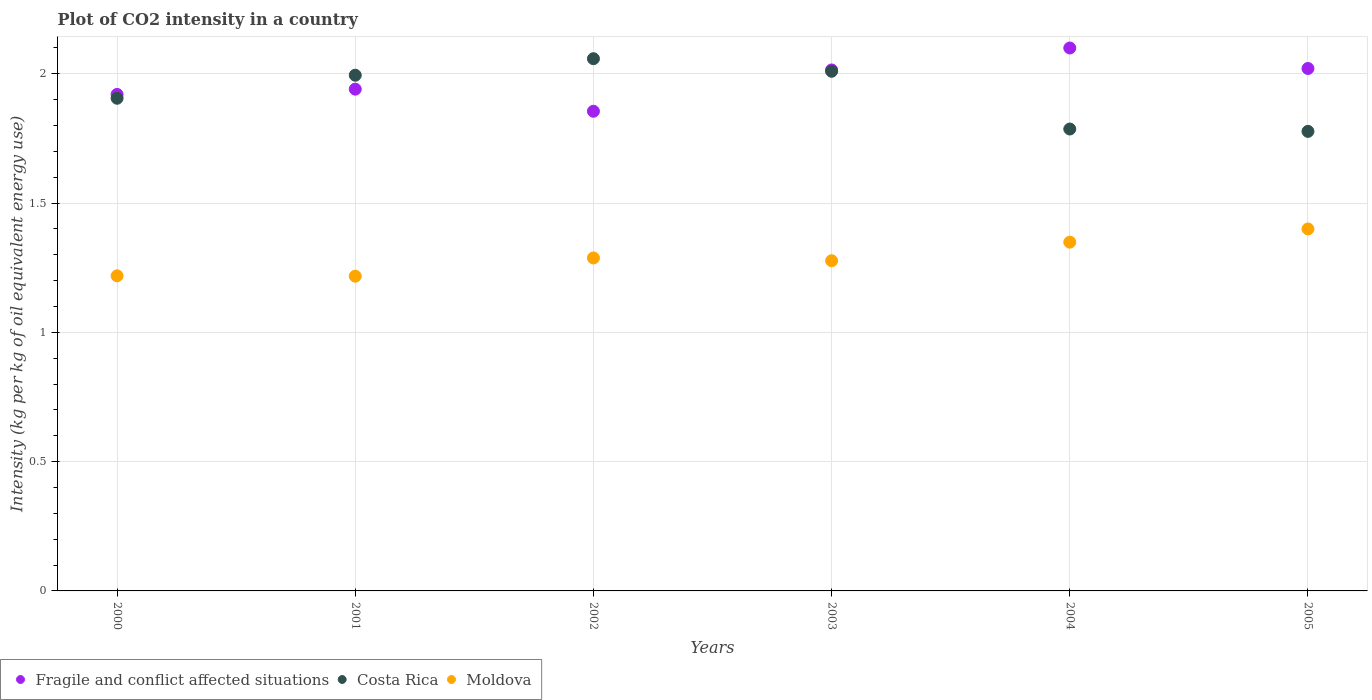What is the CO2 intensity in in Fragile and conflict affected situations in 2003?
Offer a very short reply. 2.01. Across all years, what is the maximum CO2 intensity in in Moldova?
Keep it short and to the point. 1.4. Across all years, what is the minimum CO2 intensity in in Costa Rica?
Your answer should be very brief. 1.78. In which year was the CO2 intensity in in Moldova maximum?
Keep it short and to the point. 2005. What is the total CO2 intensity in in Fragile and conflict affected situations in the graph?
Give a very brief answer. 11.85. What is the difference between the CO2 intensity in in Costa Rica in 2002 and that in 2004?
Make the answer very short. 0.27. What is the difference between the CO2 intensity in in Costa Rica in 2003 and the CO2 intensity in in Moldova in 2000?
Keep it short and to the point. 0.79. What is the average CO2 intensity in in Moldova per year?
Ensure brevity in your answer.  1.29. In the year 2003, what is the difference between the CO2 intensity in in Costa Rica and CO2 intensity in in Moldova?
Provide a short and direct response. 0.73. In how many years, is the CO2 intensity in in Fragile and conflict affected situations greater than 1.1 kg?
Provide a short and direct response. 6. What is the ratio of the CO2 intensity in in Moldova in 2002 to that in 2005?
Ensure brevity in your answer.  0.92. Is the difference between the CO2 intensity in in Costa Rica in 2000 and 2001 greater than the difference between the CO2 intensity in in Moldova in 2000 and 2001?
Your response must be concise. No. What is the difference between the highest and the second highest CO2 intensity in in Costa Rica?
Offer a very short reply. 0.05. What is the difference between the highest and the lowest CO2 intensity in in Moldova?
Ensure brevity in your answer.  0.18. Is it the case that in every year, the sum of the CO2 intensity in in Moldova and CO2 intensity in in Costa Rica  is greater than the CO2 intensity in in Fragile and conflict affected situations?
Your response must be concise. Yes. Is the CO2 intensity in in Moldova strictly greater than the CO2 intensity in in Costa Rica over the years?
Make the answer very short. No. Is the CO2 intensity in in Costa Rica strictly less than the CO2 intensity in in Fragile and conflict affected situations over the years?
Give a very brief answer. No. Are the values on the major ticks of Y-axis written in scientific E-notation?
Your answer should be compact. No. Does the graph contain any zero values?
Provide a short and direct response. No. How many legend labels are there?
Your answer should be compact. 3. What is the title of the graph?
Your response must be concise. Plot of CO2 intensity in a country. Does "Egypt, Arab Rep." appear as one of the legend labels in the graph?
Your response must be concise. No. What is the label or title of the Y-axis?
Provide a short and direct response. Intensity (kg per kg of oil equivalent energy use). What is the Intensity (kg per kg of oil equivalent energy use) of Fragile and conflict affected situations in 2000?
Offer a terse response. 1.92. What is the Intensity (kg per kg of oil equivalent energy use) of Costa Rica in 2000?
Provide a short and direct response. 1.91. What is the Intensity (kg per kg of oil equivalent energy use) in Moldova in 2000?
Give a very brief answer. 1.22. What is the Intensity (kg per kg of oil equivalent energy use) of Fragile and conflict affected situations in 2001?
Ensure brevity in your answer.  1.94. What is the Intensity (kg per kg of oil equivalent energy use) in Costa Rica in 2001?
Offer a very short reply. 1.99. What is the Intensity (kg per kg of oil equivalent energy use) in Moldova in 2001?
Your response must be concise. 1.22. What is the Intensity (kg per kg of oil equivalent energy use) of Fragile and conflict affected situations in 2002?
Your answer should be very brief. 1.85. What is the Intensity (kg per kg of oil equivalent energy use) of Costa Rica in 2002?
Ensure brevity in your answer.  2.06. What is the Intensity (kg per kg of oil equivalent energy use) in Moldova in 2002?
Provide a succinct answer. 1.29. What is the Intensity (kg per kg of oil equivalent energy use) of Fragile and conflict affected situations in 2003?
Your answer should be very brief. 2.01. What is the Intensity (kg per kg of oil equivalent energy use) in Costa Rica in 2003?
Give a very brief answer. 2.01. What is the Intensity (kg per kg of oil equivalent energy use) in Moldova in 2003?
Make the answer very short. 1.28. What is the Intensity (kg per kg of oil equivalent energy use) of Fragile and conflict affected situations in 2004?
Your answer should be compact. 2.1. What is the Intensity (kg per kg of oil equivalent energy use) in Costa Rica in 2004?
Make the answer very short. 1.79. What is the Intensity (kg per kg of oil equivalent energy use) in Moldova in 2004?
Give a very brief answer. 1.35. What is the Intensity (kg per kg of oil equivalent energy use) in Fragile and conflict affected situations in 2005?
Keep it short and to the point. 2.02. What is the Intensity (kg per kg of oil equivalent energy use) in Costa Rica in 2005?
Your response must be concise. 1.78. What is the Intensity (kg per kg of oil equivalent energy use) in Moldova in 2005?
Ensure brevity in your answer.  1.4. Across all years, what is the maximum Intensity (kg per kg of oil equivalent energy use) in Fragile and conflict affected situations?
Your response must be concise. 2.1. Across all years, what is the maximum Intensity (kg per kg of oil equivalent energy use) in Costa Rica?
Keep it short and to the point. 2.06. Across all years, what is the maximum Intensity (kg per kg of oil equivalent energy use) in Moldova?
Offer a terse response. 1.4. Across all years, what is the minimum Intensity (kg per kg of oil equivalent energy use) in Fragile and conflict affected situations?
Give a very brief answer. 1.85. Across all years, what is the minimum Intensity (kg per kg of oil equivalent energy use) in Costa Rica?
Provide a short and direct response. 1.78. Across all years, what is the minimum Intensity (kg per kg of oil equivalent energy use) in Moldova?
Offer a terse response. 1.22. What is the total Intensity (kg per kg of oil equivalent energy use) in Fragile and conflict affected situations in the graph?
Your answer should be very brief. 11.85. What is the total Intensity (kg per kg of oil equivalent energy use) in Costa Rica in the graph?
Your response must be concise. 11.53. What is the total Intensity (kg per kg of oil equivalent energy use) in Moldova in the graph?
Your response must be concise. 7.75. What is the difference between the Intensity (kg per kg of oil equivalent energy use) of Fragile and conflict affected situations in 2000 and that in 2001?
Give a very brief answer. -0.02. What is the difference between the Intensity (kg per kg of oil equivalent energy use) of Costa Rica in 2000 and that in 2001?
Give a very brief answer. -0.09. What is the difference between the Intensity (kg per kg of oil equivalent energy use) of Moldova in 2000 and that in 2001?
Ensure brevity in your answer.  0. What is the difference between the Intensity (kg per kg of oil equivalent energy use) of Fragile and conflict affected situations in 2000 and that in 2002?
Make the answer very short. 0.07. What is the difference between the Intensity (kg per kg of oil equivalent energy use) of Costa Rica in 2000 and that in 2002?
Provide a succinct answer. -0.15. What is the difference between the Intensity (kg per kg of oil equivalent energy use) in Moldova in 2000 and that in 2002?
Offer a terse response. -0.07. What is the difference between the Intensity (kg per kg of oil equivalent energy use) in Fragile and conflict affected situations in 2000 and that in 2003?
Ensure brevity in your answer.  -0.09. What is the difference between the Intensity (kg per kg of oil equivalent energy use) of Costa Rica in 2000 and that in 2003?
Offer a terse response. -0.1. What is the difference between the Intensity (kg per kg of oil equivalent energy use) of Moldova in 2000 and that in 2003?
Offer a very short reply. -0.06. What is the difference between the Intensity (kg per kg of oil equivalent energy use) of Fragile and conflict affected situations in 2000 and that in 2004?
Make the answer very short. -0.18. What is the difference between the Intensity (kg per kg of oil equivalent energy use) of Costa Rica in 2000 and that in 2004?
Ensure brevity in your answer.  0.12. What is the difference between the Intensity (kg per kg of oil equivalent energy use) in Moldova in 2000 and that in 2004?
Ensure brevity in your answer.  -0.13. What is the difference between the Intensity (kg per kg of oil equivalent energy use) of Fragile and conflict affected situations in 2000 and that in 2005?
Make the answer very short. -0.1. What is the difference between the Intensity (kg per kg of oil equivalent energy use) of Costa Rica in 2000 and that in 2005?
Your answer should be compact. 0.13. What is the difference between the Intensity (kg per kg of oil equivalent energy use) of Moldova in 2000 and that in 2005?
Offer a terse response. -0.18. What is the difference between the Intensity (kg per kg of oil equivalent energy use) in Fragile and conflict affected situations in 2001 and that in 2002?
Give a very brief answer. 0.09. What is the difference between the Intensity (kg per kg of oil equivalent energy use) in Costa Rica in 2001 and that in 2002?
Provide a short and direct response. -0.06. What is the difference between the Intensity (kg per kg of oil equivalent energy use) in Moldova in 2001 and that in 2002?
Your answer should be compact. -0.07. What is the difference between the Intensity (kg per kg of oil equivalent energy use) of Fragile and conflict affected situations in 2001 and that in 2003?
Provide a short and direct response. -0.07. What is the difference between the Intensity (kg per kg of oil equivalent energy use) of Costa Rica in 2001 and that in 2003?
Your answer should be compact. -0.02. What is the difference between the Intensity (kg per kg of oil equivalent energy use) of Moldova in 2001 and that in 2003?
Your answer should be compact. -0.06. What is the difference between the Intensity (kg per kg of oil equivalent energy use) in Fragile and conflict affected situations in 2001 and that in 2004?
Your answer should be very brief. -0.16. What is the difference between the Intensity (kg per kg of oil equivalent energy use) in Costa Rica in 2001 and that in 2004?
Provide a short and direct response. 0.21. What is the difference between the Intensity (kg per kg of oil equivalent energy use) of Moldova in 2001 and that in 2004?
Your answer should be compact. -0.13. What is the difference between the Intensity (kg per kg of oil equivalent energy use) of Fragile and conflict affected situations in 2001 and that in 2005?
Make the answer very short. -0.08. What is the difference between the Intensity (kg per kg of oil equivalent energy use) in Costa Rica in 2001 and that in 2005?
Give a very brief answer. 0.22. What is the difference between the Intensity (kg per kg of oil equivalent energy use) in Moldova in 2001 and that in 2005?
Provide a short and direct response. -0.18. What is the difference between the Intensity (kg per kg of oil equivalent energy use) in Fragile and conflict affected situations in 2002 and that in 2003?
Keep it short and to the point. -0.16. What is the difference between the Intensity (kg per kg of oil equivalent energy use) of Costa Rica in 2002 and that in 2003?
Your response must be concise. 0.05. What is the difference between the Intensity (kg per kg of oil equivalent energy use) in Moldova in 2002 and that in 2003?
Provide a short and direct response. 0.01. What is the difference between the Intensity (kg per kg of oil equivalent energy use) of Fragile and conflict affected situations in 2002 and that in 2004?
Make the answer very short. -0.24. What is the difference between the Intensity (kg per kg of oil equivalent energy use) of Costa Rica in 2002 and that in 2004?
Your response must be concise. 0.27. What is the difference between the Intensity (kg per kg of oil equivalent energy use) in Moldova in 2002 and that in 2004?
Your answer should be very brief. -0.06. What is the difference between the Intensity (kg per kg of oil equivalent energy use) in Fragile and conflict affected situations in 2002 and that in 2005?
Your response must be concise. -0.17. What is the difference between the Intensity (kg per kg of oil equivalent energy use) in Costa Rica in 2002 and that in 2005?
Your answer should be compact. 0.28. What is the difference between the Intensity (kg per kg of oil equivalent energy use) of Moldova in 2002 and that in 2005?
Your answer should be very brief. -0.11. What is the difference between the Intensity (kg per kg of oil equivalent energy use) in Fragile and conflict affected situations in 2003 and that in 2004?
Give a very brief answer. -0.08. What is the difference between the Intensity (kg per kg of oil equivalent energy use) in Costa Rica in 2003 and that in 2004?
Ensure brevity in your answer.  0.22. What is the difference between the Intensity (kg per kg of oil equivalent energy use) of Moldova in 2003 and that in 2004?
Offer a very short reply. -0.07. What is the difference between the Intensity (kg per kg of oil equivalent energy use) of Fragile and conflict affected situations in 2003 and that in 2005?
Give a very brief answer. -0.01. What is the difference between the Intensity (kg per kg of oil equivalent energy use) in Costa Rica in 2003 and that in 2005?
Keep it short and to the point. 0.23. What is the difference between the Intensity (kg per kg of oil equivalent energy use) of Moldova in 2003 and that in 2005?
Make the answer very short. -0.12. What is the difference between the Intensity (kg per kg of oil equivalent energy use) of Fragile and conflict affected situations in 2004 and that in 2005?
Offer a terse response. 0.08. What is the difference between the Intensity (kg per kg of oil equivalent energy use) in Costa Rica in 2004 and that in 2005?
Provide a succinct answer. 0.01. What is the difference between the Intensity (kg per kg of oil equivalent energy use) of Moldova in 2004 and that in 2005?
Offer a very short reply. -0.05. What is the difference between the Intensity (kg per kg of oil equivalent energy use) of Fragile and conflict affected situations in 2000 and the Intensity (kg per kg of oil equivalent energy use) of Costa Rica in 2001?
Provide a short and direct response. -0.07. What is the difference between the Intensity (kg per kg of oil equivalent energy use) in Fragile and conflict affected situations in 2000 and the Intensity (kg per kg of oil equivalent energy use) in Moldova in 2001?
Give a very brief answer. 0.7. What is the difference between the Intensity (kg per kg of oil equivalent energy use) of Costa Rica in 2000 and the Intensity (kg per kg of oil equivalent energy use) of Moldova in 2001?
Your response must be concise. 0.69. What is the difference between the Intensity (kg per kg of oil equivalent energy use) of Fragile and conflict affected situations in 2000 and the Intensity (kg per kg of oil equivalent energy use) of Costa Rica in 2002?
Your answer should be very brief. -0.14. What is the difference between the Intensity (kg per kg of oil equivalent energy use) in Fragile and conflict affected situations in 2000 and the Intensity (kg per kg of oil equivalent energy use) in Moldova in 2002?
Provide a succinct answer. 0.63. What is the difference between the Intensity (kg per kg of oil equivalent energy use) in Costa Rica in 2000 and the Intensity (kg per kg of oil equivalent energy use) in Moldova in 2002?
Offer a very short reply. 0.62. What is the difference between the Intensity (kg per kg of oil equivalent energy use) of Fragile and conflict affected situations in 2000 and the Intensity (kg per kg of oil equivalent energy use) of Costa Rica in 2003?
Your answer should be very brief. -0.09. What is the difference between the Intensity (kg per kg of oil equivalent energy use) in Fragile and conflict affected situations in 2000 and the Intensity (kg per kg of oil equivalent energy use) in Moldova in 2003?
Offer a terse response. 0.64. What is the difference between the Intensity (kg per kg of oil equivalent energy use) in Costa Rica in 2000 and the Intensity (kg per kg of oil equivalent energy use) in Moldova in 2003?
Provide a short and direct response. 0.63. What is the difference between the Intensity (kg per kg of oil equivalent energy use) in Fragile and conflict affected situations in 2000 and the Intensity (kg per kg of oil equivalent energy use) in Costa Rica in 2004?
Provide a short and direct response. 0.13. What is the difference between the Intensity (kg per kg of oil equivalent energy use) of Fragile and conflict affected situations in 2000 and the Intensity (kg per kg of oil equivalent energy use) of Moldova in 2004?
Ensure brevity in your answer.  0.57. What is the difference between the Intensity (kg per kg of oil equivalent energy use) in Costa Rica in 2000 and the Intensity (kg per kg of oil equivalent energy use) in Moldova in 2004?
Make the answer very short. 0.56. What is the difference between the Intensity (kg per kg of oil equivalent energy use) of Fragile and conflict affected situations in 2000 and the Intensity (kg per kg of oil equivalent energy use) of Costa Rica in 2005?
Offer a very short reply. 0.14. What is the difference between the Intensity (kg per kg of oil equivalent energy use) in Fragile and conflict affected situations in 2000 and the Intensity (kg per kg of oil equivalent energy use) in Moldova in 2005?
Ensure brevity in your answer.  0.52. What is the difference between the Intensity (kg per kg of oil equivalent energy use) of Costa Rica in 2000 and the Intensity (kg per kg of oil equivalent energy use) of Moldova in 2005?
Your response must be concise. 0.51. What is the difference between the Intensity (kg per kg of oil equivalent energy use) in Fragile and conflict affected situations in 2001 and the Intensity (kg per kg of oil equivalent energy use) in Costa Rica in 2002?
Make the answer very short. -0.12. What is the difference between the Intensity (kg per kg of oil equivalent energy use) of Fragile and conflict affected situations in 2001 and the Intensity (kg per kg of oil equivalent energy use) of Moldova in 2002?
Make the answer very short. 0.65. What is the difference between the Intensity (kg per kg of oil equivalent energy use) of Costa Rica in 2001 and the Intensity (kg per kg of oil equivalent energy use) of Moldova in 2002?
Your response must be concise. 0.71. What is the difference between the Intensity (kg per kg of oil equivalent energy use) in Fragile and conflict affected situations in 2001 and the Intensity (kg per kg of oil equivalent energy use) in Costa Rica in 2003?
Provide a succinct answer. -0.07. What is the difference between the Intensity (kg per kg of oil equivalent energy use) in Fragile and conflict affected situations in 2001 and the Intensity (kg per kg of oil equivalent energy use) in Moldova in 2003?
Ensure brevity in your answer.  0.66. What is the difference between the Intensity (kg per kg of oil equivalent energy use) in Costa Rica in 2001 and the Intensity (kg per kg of oil equivalent energy use) in Moldova in 2003?
Ensure brevity in your answer.  0.72. What is the difference between the Intensity (kg per kg of oil equivalent energy use) of Fragile and conflict affected situations in 2001 and the Intensity (kg per kg of oil equivalent energy use) of Costa Rica in 2004?
Give a very brief answer. 0.15. What is the difference between the Intensity (kg per kg of oil equivalent energy use) of Fragile and conflict affected situations in 2001 and the Intensity (kg per kg of oil equivalent energy use) of Moldova in 2004?
Offer a very short reply. 0.59. What is the difference between the Intensity (kg per kg of oil equivalent energy use) in Costa Rica in 2001 and the Intensity (kg per kg of oil equivalent energy use) in Moldova in 2004?
Your response must be concise. 0.65. What is the difference between the Intensity (kg per kg of oil equivalent energy use) in Fragile and conflict affected situations in 2001 and the Intensity (kg per kg of oil equivalent energy use) in Costa Rica in 2005?
Offer a very short reply. 0.16. What is the difference between the Intensity (kg per kg of oil equivalent energy use) of Fragile and conflict affected situations in 2001 and the Intensity (kg per kg of oil equivalent energy use) of Moldova in 2005?
Keep it short and to the point. 0.54. What is the difference between the Intensity (kg per kg of oil equivalent energy use) in Costa Rica in 2001 and the Intensity (kg per kg of oil equivalent energy use) in Moldova in 2005?
Give a very brief answer. 0.59. What is the difference between the Intensity (kg per kg of oil equivalent energy use) of Fragile and conflict affected situations in 2002 and the Intensity (kg per kg of oil equivalent energy use) of Costa Rica in 2003?
Your answer should be very brief. -0.15. What is the difference between the Intensity (kg per kg of oil equivalent energy use) of Fragile and conflict affected situations in 2002 and the Intensity (kg per kg of oil equivalent energy use) of Moldova in 2003?
Ensure brevity in your answer.  0.58. What is the difference between the Intensity (kg per kg of oil equivalent energy use) of Costa Rica in 2002 and the Intensity (kg per kg of oil equivalent energy use) of Moldova in 2003?
Ensure brevity in your answer.  0.78. What is the difference between the Intensity (kg per kg of oil equivalent energy use) of Fragile and conflict affected situations in 2002 and the Intensity (kg per kg of oil equivalent energy use) of Costa Rica in 2004?
Make the answer very short. 0.07. What is the difference between the Intensity (kg per kg of oil equivalent energy use) of Fragile and conflict affected situations in 2002 and the Intensity (kg per kg of oil equivalent energy use) of Moldova in 2004?
Give a very brief answer. 0.51. What is the difference between the Intensity (kg per kg of oil equivalent energy use) of Costa Rica in 2002 and the Intensity (kg per kg of oil equivalent energy use) of Moldova in 2004?
Offer a very short reply. 0.71. What is the difference between the Intensity (kg per kg of oil equivalent energy use) in Fragile and conflict affected situations in 2002 and the Intensity (kg per kg of oil equivalent energy use) in Costa Rica in 2005?
Give a very brief answer. 0.08. What is the difference between the Intensity (kg per kg of oil equivalent energy use) in Fragile and conflict affected situations in 2002 and the Intensity (kg per kg of oil equivalent energy use) in Moldova in 2005?
Ensure brevity in your answer.  0.46. What is the difference between the Intensity (kg per kg of oil equivalent energy use) in Costa Rica in 2002 and the Intensity (kg per kg of oil equivalent energy use) in Moldova in 2005?
Offer a terse response. 0.66. What is the difference between the Intensity (kg per kg of oil equivalent energy use) in Fragile and conflict affected situations in 2003 and the Intensity (kg per kg of oil equivalent energy use) in Costa Rica in 2004?
Offer a terse response. 0.23. What is the difference between the Intensity (kg per kg of oil equivalent energy use) of Fragile and conflict affected situations in 2003 and the Intensity (kg per kg of oil equivalent energy use) of Moldova in 2004?
Ensure brevity in your answer.  0.67. What is the difference between the Intensity (kg per kg of oil equivalent energy use) in Costa Rica in 2003 and the Intensity (kg per kg of oil equivalent energy use) in Moldova in 2004?
Your response must be concise. 0.66. What is the difference between the Intensity (kg per kg of oil equivalent energy use) in Fragile and conflict affected situations in 2003 and the Intensity (kg per kg of oil equivalent energy use) in Costa Rica in 2005?
Ensure brevity in your answer.  0.24. What is the difference between the Intensity (kg per kg of oil equivalent energy use) of Fragile and conflict affected situations in 2003 and the Intensity (kg per kg of oil equivalent energy use) of Moldova in 2005?
Ensure brevity in your answer.  0.61. What is the difference between the Intensity (kg per kg of oil equivalent energy use) in Costa Rica in 2003 and the Intensity (kg per kg of oil equivalent energy use) in Moldova in 2005?
Your answer should be very brief. 0.61. What is the difference between the Intensity (kg per kg of oil equivalent energy use) of Fragile and conflict affected situations in 2004 and the Intensity (kg per kg of oil equivalent energy use) of Costa Rica in 2005?
Provide a short and direct response. 0.32. What is the difference between the Intensity (kg per kg of oil equivalent energy use) in Fragile and conflict affected situations in 2004 and the Intensity (kg per kg of oil equivalent energy use) in Moldova in 2005?
Provide a succinct answer. 0.7. What is the difference between the Intensity (kg per kg of oil equivalent energy use) in Costa Rica in 2004 and the Intensity (kg per kg of oil equivalent energy use) in Moldova in 2005?
Ensure brevity in your answer.  0.39. What is the average Intensity (kg per kg of oil equivalent energy use) in Fragile and conflict affected situations per year?
Give a very brief answer. 1.98. What is the average Intensity (kg per kg of oil equivalent energy use) of Costa Rica per year?
Offer a very short reply. 1.92. What is the average Intensity (kg per kg of oil equivalent energy use) in Moldova per year?
Your response must be concise. 1.29. In the year 2000, what is the difference between the Intensity (kg per kg of oil equivalent energy use) in Fragile and conflict affected situations and Intensity (kg per kg of oil equivalent energy use) in Costa Rica?
Give a very brief answer. 0.01. In the year 2000, what is the difference between the Intensity (kg per kg of oil equivalent energy use) of Fragile and conflict affected situations and Intensity (kg per kg of oil equivalent energy use) of Moldova?
Your answer should be very brief. 0.7. In the year 2000, what is the difference between the Intensity (kg per kg of oil equivalent energy use) of Costa Rica and Intensity (kg per kg of oil equivalent energy use) of Moldova?
Offer a terse response. 0.69. In the year 2001, what is the difference between the Intensity (kg per kg of oil equivalent energy use) of Fragile and conflict affected situations and Intensity (kg per kg of oil equivalent energy use) of Costa Rica?
Offer a very short reply. -0.05. In the year 2001, what is the difference between the Intensity (kg per kg of oil equivalent energy use) of Fragile and conflict affected situations and Intensity (kg per kg of oil equivalent energy use) of Moldova?
Make the answer very short. 0.72. In the year 2001, what is the difference between the Intensity (kg per kg of oil equivalent energy use) in Costa Rica and Intensity (kg per kg of oil equivalent energy use) in Moldova?
Offer a very short reply. 0.78. In the year 2002, what is the difference between the Intensity (kg per kg of oil equivalent energy use) in Fragile and conflict affected situations and Intensity (kg per kg of oil equivalent energy use) in Costa Rica?
Make the answer very short. -0.2. In the year 2002, what is the difference between the Intensity (kg per kg of oil equivalent energy use) of Fragile and conflict affected situations and Intensity (kg per kg of oil equivalent energy use) of Moldova?
Provide a succinct answer. 0.57. In the year 2002, what is the difference between the Intensity (kg per kg of oil equivalent energy use) of Costa Rica and Intensity (kg per kg of oil equivalent energy use) of Moldova?
Offer a terse response. 0.77. In the year 2003, what is the difference between the Intensity (kg per kg of oil equivalent energy use) in Fragile and conflict affected situations and Intensity (kg per kg of oil equivalent energy use) in Costa Rica?
Provide a succinct answer. 0.01. In the year 2003, what is the difference between the Intensity (kg per kg of oil equivalent energy use) of Fragile and conflict affected situations and Intensity (kg per kg of oil equivalent energy use) of Moldova?
Make the answer very short. 0.74. In the year 2003, what is the difference between the Intensity (kg per kg of oil equivalent energy use) of Costa Rica and Intensity (kg per kg of oil equivalent energy use) of Moldova?
Your answer should be compact. 0.73. In the year 2004, what is the difference between the Intensity (kg per kg of oil equivalent energy use) in Fragile and conflict affected situations and Intensity (kg per kg of oil equivalent energy use) in Costa Rica?
Your answer should be very brief. 0.31. In the year 2004, what is the difference between the Intensity (kg per kg of oil equivalent energy use) of Fragile and conflict affected situations and Intensity (kg per kg of oil equivalent energy use) of Moldova?
Offer a very short reply. 0.75. In the year 2004, what is the difference between the Intensity (kg per kg of oil equivalent energy use) in Costa Rica and Intensity (kg per kg of oil equivalent energy use) in Moldova?
Offer a terse response. 0.44. In the year 2005, what is the difference between the Intensity (kg per kg of oil equivalent energy use) in Fragile and conflict affected situations and Intensity (kg per kg of oil equivalent energy use) in Costa Rica?
Provide a succinct answer. 0.24. In the year 2005, what is the difference between the Intensity (kg per kg of oil equivalent energy use) in Fragile and conflict affected situations and Intensity (kg per kg of oil equivalent energy use) in Moldova?
Keep it short and to the point. 0.62. In the year 2005, what is the difference between the Intensity (kg per kg of oil equivalent energy use) in Costa Rica and Intensity (kg per kg of oil equivalent energy use) in Moldova?
Offer a very short reply. 0.38. What is the ratio of the Intensity (kg per kg of oil equivalent energy use) of Fragile and conflict affected situations in 2000 to that in 2001?
Your answer should be very brief. 0.99. What is the ratio of the Intensity (kg per kg of oil equivalent energy use) of Costa Rica in 2000 to that in 2001?
Ensure brevity in your answer.  0.96. What is the ratio of the Intensity (kg per kg of oil equivalent energy use) of Fragile and conflict affected situations in 2000 to that in 2002?
Provide a short and direct response. 1.04. What is the ratio of the Intensity (kg per kg of oil equivalent energy use) in Costa Rica in 2000 to that in 2002?
Offer a terse response. 0.93. What is the ratio of the Intensity (kg per kg of oil equivalent energy use) of Moldova in 2000 to that in 2002?
Your answer should be very brief. 0.95. What is the ratio of the Intensity (kg per kg of oil equivalent energy use) in Fragile and conflict affected situations in 2000 to that in 2003?
Make the answer very short. 0.95. What is the ratio of the Intensity (kg per kg of oil equivalent energy use) in Costa Rica in 2000 to that in 2003?
Your response must be concise. 0.95. What is the ratio of the Intensity (kg per kg of oil equivalent energy use) in Moldova in 2000 to that in 2003?
Offer a terse response. 0.95. What is the ratio of the Intensity (kg per kg of oil equivalent energy use) in Fragile and conflict affected situations in 2000 to that in 2004?
Offer a terse response. 0.91. What is the ratio of the Intensity (kg per kg of oil equivalent energy use) in Costa Rica in 2000 to that in 2004?
Provide a succinct answer. 1.07. What is the ratio of the Intensity (kg per kg of oil equivalent energy use) in Moldova in 2000 to that in 2004?
Give a very brief answer. 0.9. What is the ratio of the Intensity (kg per kg of oil equivalent energy use) in Fragile and conflict affected situations in 2000 to that in 2005?
Provide a short and direct response. 0.95. What is the ratio of the Intensity (kg per kg of oil equivalent energy use) of Costa Rica in 2000 to that in 2005?
Offer a very short reply. 1.07. What is the ratio of the Intensity (kg per kg of oil equivalent energy use) in Moldova in 2000 to that in 2005?
Provide a succinct answer. 0.87. What is the ratio of the Intensity (kg per kg of oil equivalent energy use) of Fragile and conflict affected situations in 2001 to that in 2002?
Offer a very short reply. 1.05. What is the ratio of the Intensity (kg per kg of oil equivalent energy use) of Moldova in 2001 to that in 2002?
Keep it short and to the point. 0.95. What is the ratio of the Intensity (kg per kg of oil equivalent energy use) of Fragile and conflict affected situations in 2001 to that in 2003?
Your response must be concise. 0.96. What is the ratio of the Intensity (kg per kg of oil equivalent energy use) in Costa Rica in 2001 to that in 2003?
Offer a very short reply. 0.99. What is the ratio of the Intensity (kg per kg of oil equivalent energy use) of Moldova in 2001 to that in 2003?
Offer a terse response. 0.95. What is the ratio of the Intensity (kg per kg of oil equivalent energy use) of Fragile and conflict affected situations in 2001 to that in 2004?
Ensure brevity in your answer.  0.92. What is the ratio of the Intensity (kg per kg of oil equivalent energy use) in Costa Rica in 2001 to that in 2004?
Offer a terse response. 1.12. What is the ratio of the Intensity (kg per kg of oil equivalent energy use) in Moldova in 2001 to that in 2004?
Keep it short and to the point. 0.9. What is the ratio of the Intensity (kg per kg of oil equivalent energy use) of Fragile and conflict affected situations in 2001 to that in 2005?
Ensure brevity in your answer.  0.96. What is the ratio of the Intensity (kg per kg of oil equivalent energy use) of Costa Rica in 2001 to that in 2005?
Offer a very short reply. 1.12. What is the ratio of the Intensity (kg per kg of oil equivalent energy use) in Moldova in 2001 to that in 2005?
Ensure brevity in your answer.  0.87. What is the ratio of the Intensity (kg per kg of oil equivalent energy use) in Fragile and conflict affected situations in 2002 to that in 2003?
Offer a very short reply. 0.92. What is the ratio of the Intensity (kg per kg of oil equivalent energy use) in Costa Rica in 2002 to that in 2003?
Provide a succinct answer. 1.02. What is the ratio of the Intensity (kg per kg of oil equivalent energy use) of Moldova in 2002 to that in 2003?
Give a very brief answer. 1.01. What is the ratio of the Intensity (kg per kg of oil equivalent energy use) of Fragile and conflict affected situations in 2002 to that in 2004?
Offer a terse response. 0.88. What is the ratio of the Intensity (kg per kg of oil equivalent energy use) in Costa Rica in 2002 to that in 2004?
Give a very brief answer. 1.15. What is the ratio of the Intensity (kg per kg of oil equivalent energy use) of Moldova in 2002 to that in 2004?
Offer a terse response. 0.95. What is the ratio of the Intensity (kg per kg of oil equivalent energy use) of Fragile and conflict affected situations in 2002 to that in 2005?
Your answer should be very brief. 0.92. What is the ratio of the Intensity (kg per kg of oil equivalent energy use) in Costa Rica in 2002 to that in 2005?
Keep it short and to the point. 1.16. What is the ratio of the Intensity (kg per kg of oil equivalent energy use) in Moldova in 2002 to that in 2005?
Offer a very short reply. 0.92. What is the ratio of the Intensity (kg per kg of oil equivalent energy use) of Fragile and conflict affected situations in 2003 to that in 2004?
Make the answer very short. 0.96. What is the ratio of the Intensity (kg per kg of oil equivalent energy use) in Costa Rica in 2003 to that in 2004?
Offer a terse response. 1.12. What is the ratio of the Intensity (kg per kg of oil equivalent energy use) of Moldova in 2003 to that in 2004?
Keep it short and to the point. 0.95. What is the ratio of the Intensity (kg per kg of oil equivalent energy use) of Costa Rica in 2003 to that in 2005?
Keep it short and to the point. 1.13. What is the ratio of the Intensity (kg per kg of oil equivalent energy use) of Moldova in 2003 to that in 2005?
Make the answer very short. 0.91. What is the ratio of the Intensity (kg per kg of oil equivalent energy use) of Fragile and conflict affected situations in 2004 to that in 2005?
Your response must be concise. 1.04. What is the ratio of the Intensity (kg per kg of oil equivalent energy use) of Costa Rica in 2004 to that in 2005?
Your answer should be very brief. 1.01. What is the ratio of the Intensity (kg per kg of oil equivalent energy use) in Moldova in 2004 to that in 2005?
Your answer should be compact. 0.96. What is the difference between the highest and the second highest Intensity (kg per kg of oil equivalent energy use) of Fragile and conflict affected situations?
Your response must be concise. 0.08. What is the difference between the highest and the second highest Intensity (kg per kg of oil equivalent energy use) of Costa Rica?
Your answer should be compact. 0.05. What is the difference between the highest and the second highest Intensity (kg per kg of oil equivalent energy use) of Moldova?
Provide a succinct answer. 0.05. What is the difference between the highest and the lowest Intensity (kg per kg of oil equivalent energy use) of Fragile and conflict affected situations?
Keep it short and to the point. 0.24. What is the difference between the highest and the lowest Intensity (kg per kg of oil equivalent energy use) of Costa Rica?
Make the answer very short. 0.28. What is the difference between the highest and the lowest Intensity (kg per kg of oil equivalent energy use) in Moldova?
Your answer should be compact. 0.18. 